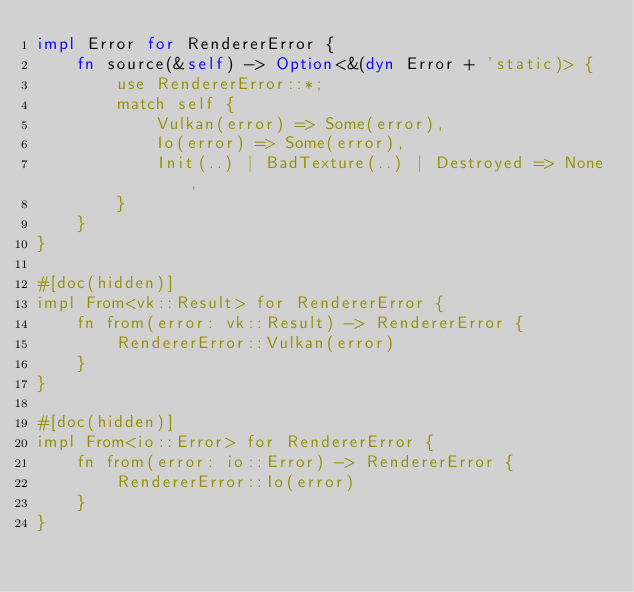Convert code to text. <code><loc_0><loc_0><loc_500><loc_500><_Rust_>impl Error for RendererError {
    fn source(&self) -> Option<&(dyn Error + 'static)> {
        use RendererError::*;
        match self {
            Vulkan(error) => Some(error),
            Io(error) => Some(error),
            Init(..) | BadTexture(..) | Destroyed => None,
        }
    }
}

#[doc(hidden)]
impl From<vk::Result> for RendererError {
    fn from(error: vk::Result) -> RendererError {
        RendererError::Vulkan(error)
    }
}

#[doc(hidden)]
impl From<io::Error> for RendererError {
    fn from(error: io::Error) -> RendererError {
        RendererError::Io(error)
    }
}
</code> 